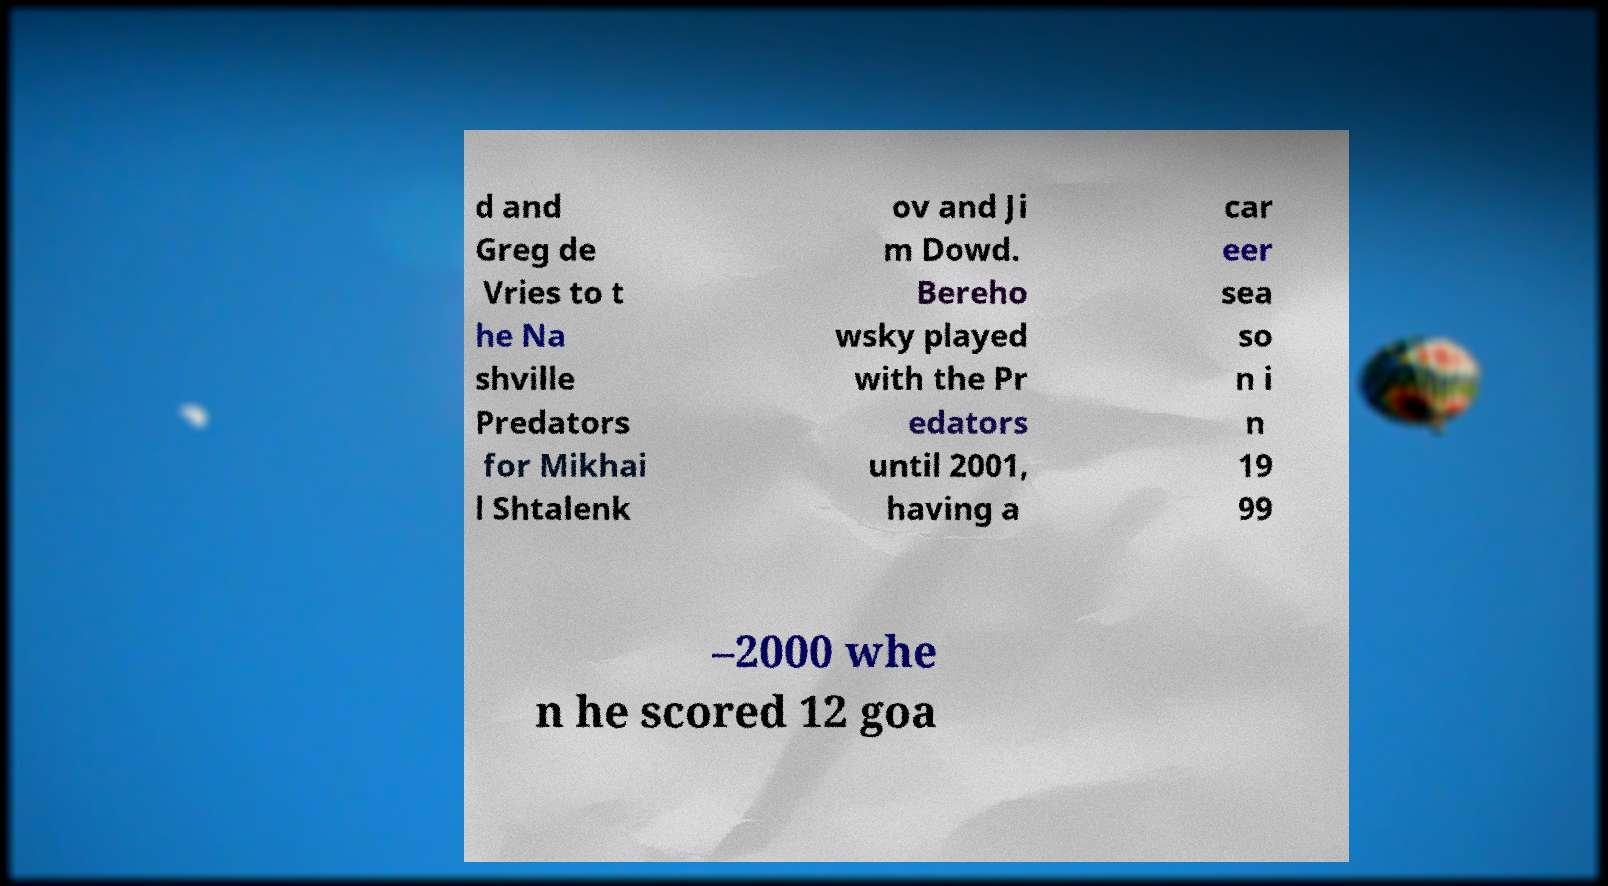Could you assist in decoding the text presented in this image and type it out clearly? d and Greg de Vries to t he Na shville Predators for Mikhai l Shtalenk ov and Ji m Dowd. Bereho wsky played with the Pr edators until 2001, having a car eer sea so n i n 19 99 –2000 whe n he scored 12 goa 